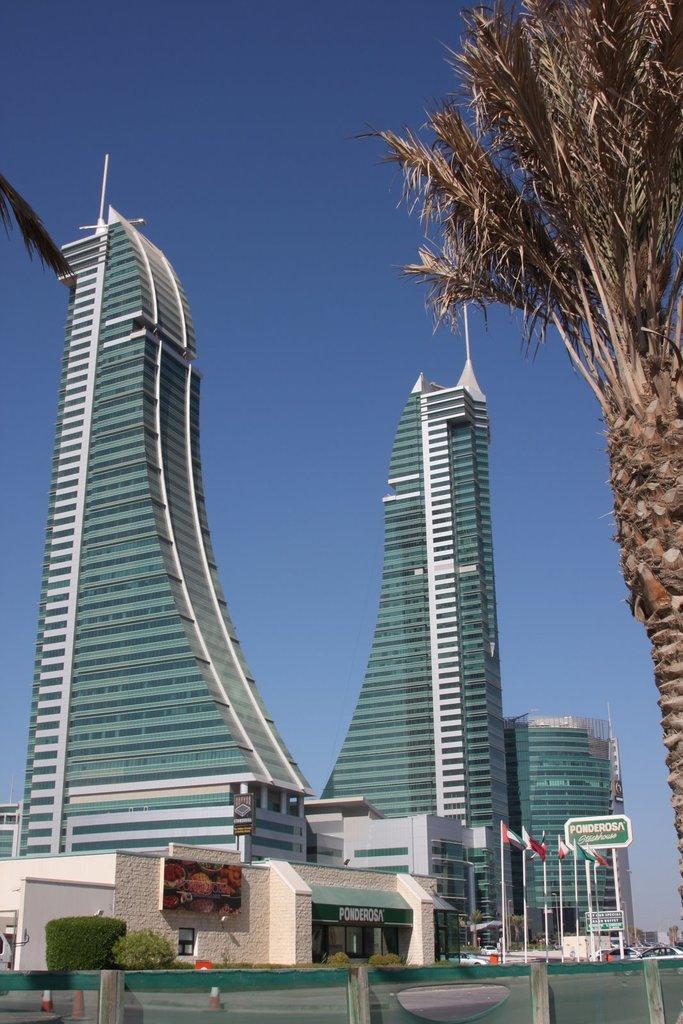Can you describe this image briefly? In this picture we can see buildings and trees, here we can see flags, boards and some objects and we can see sky in the background. 